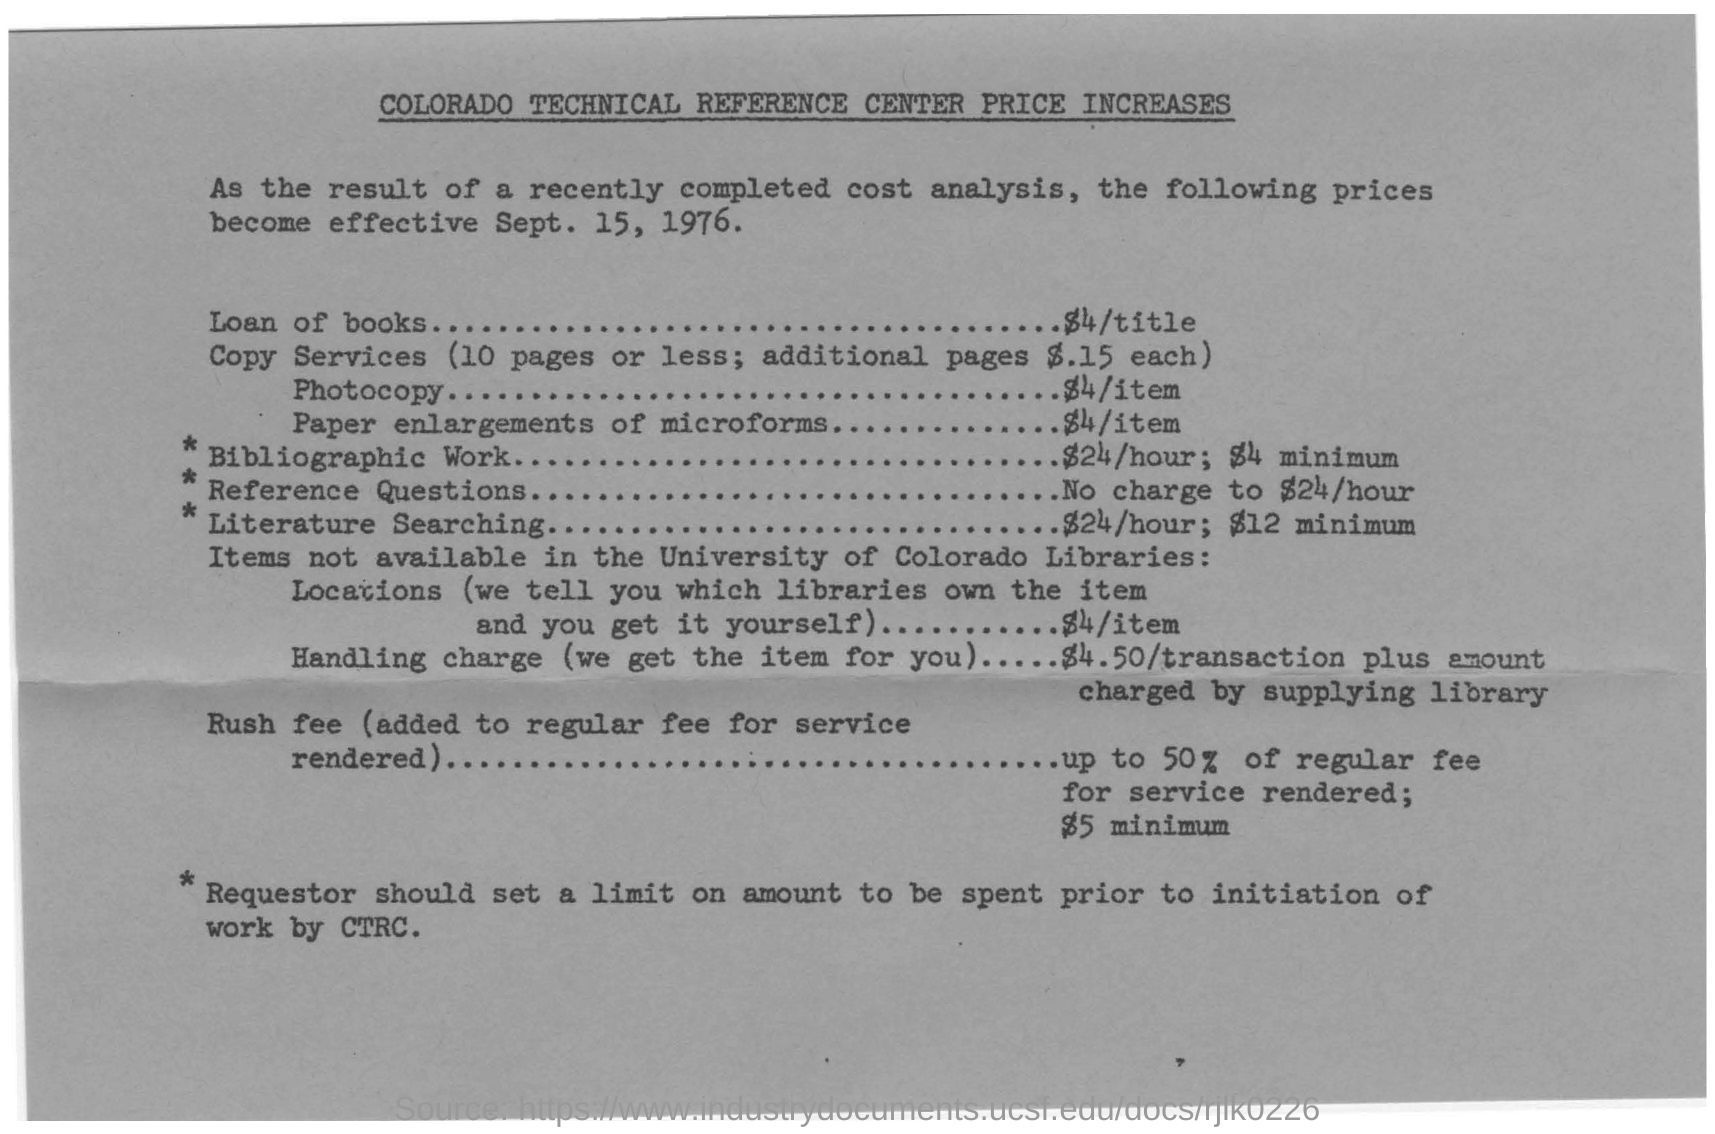What is the title of the document?
Make the answer very short. COLORADO TECHNICAL REFERENCE CENTER PRICE INCREASES. What is the date on the bill?
Keep it short and to the point. Sept. 15, 1976. What is the cost to  loan books?
Your answer should be very brief. $4/TITLE. What is the cost of the photocopy?
Make the answer very short. $4/ITEM. 